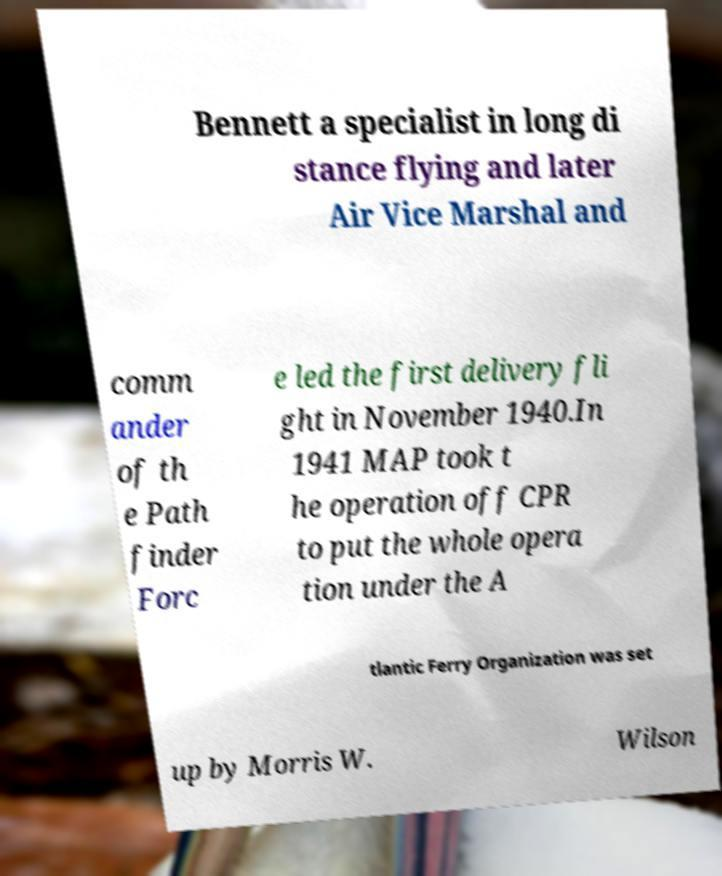Can you read and provide the text displayed in the image?This photo seems to have some interesting text. Can you extract and type it out for me? Bennett a specialist in long di stance flying and later Air Vice Marshal and comm ander of th e Path finder Forc e led the first delivery fli ght in November 1940.In 1941 MAP took t he operation off CPR to put the whole opera tion under the A tlantic Ferry Organization was set up by Morris W. Wilson 